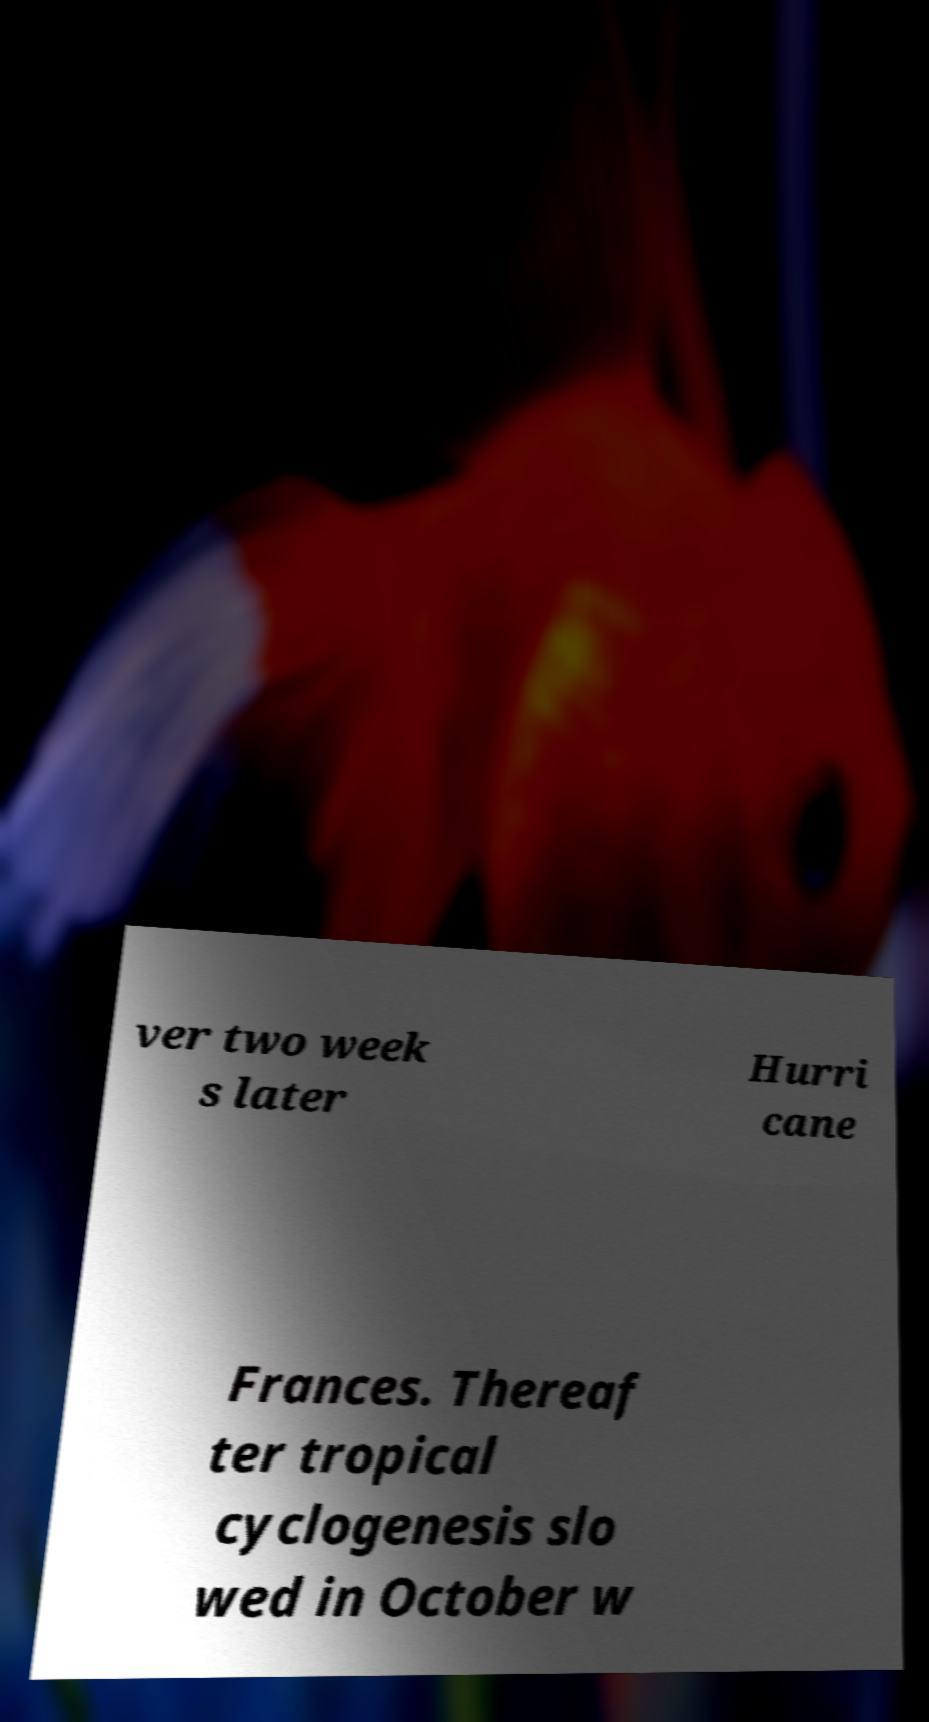For documentation purposes, I need the text within this image transcribed. Could you provide that? ver two week s later Hurri cane Frances. Thereaf ter tropical cyclogenesis slo wed in October w 